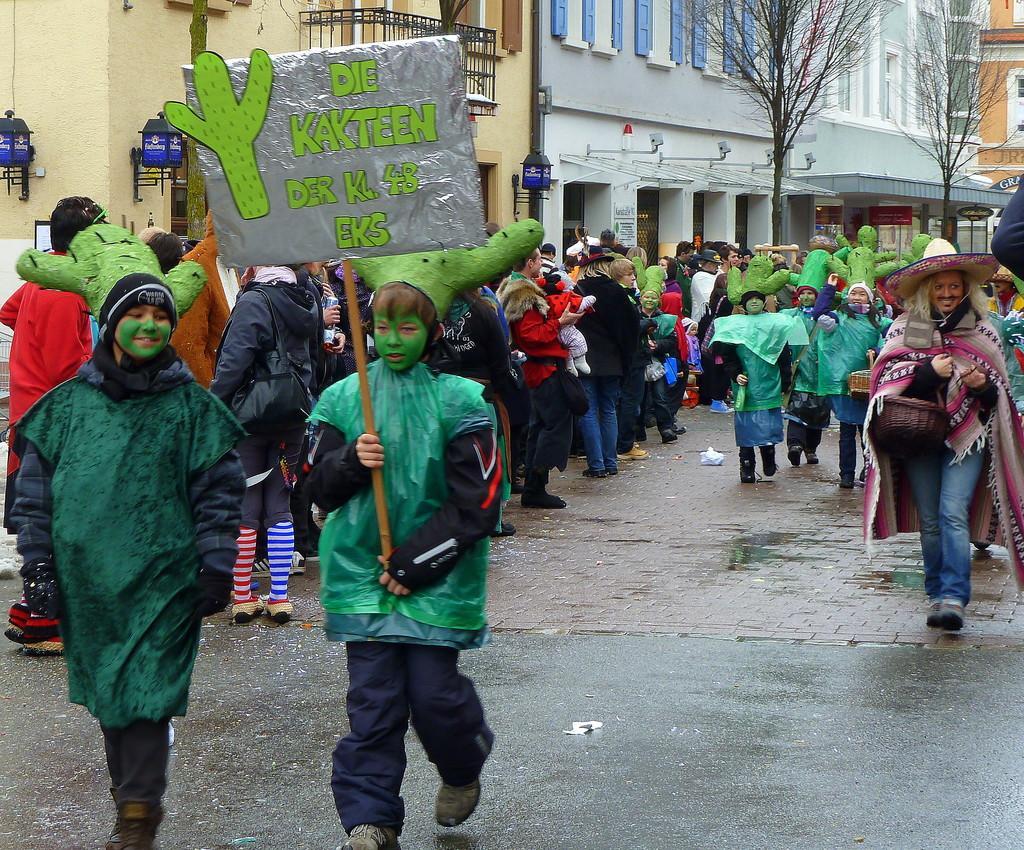Can you describe this image briefly? In the foreground of this image, there are two boys walking on the road and a boy is holding a placard. They are having a plant like a hat on their heads. In the background, there are persons walking on the road, buildings, trees, lamps and the railing. 